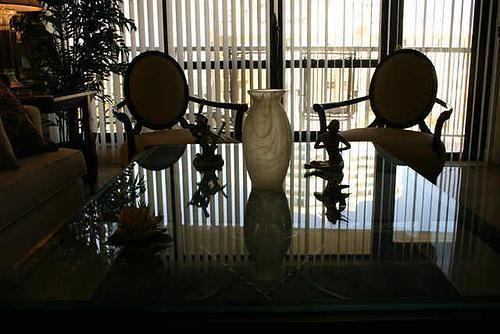How many chairs are there?
Give a very brief answer. 2. 